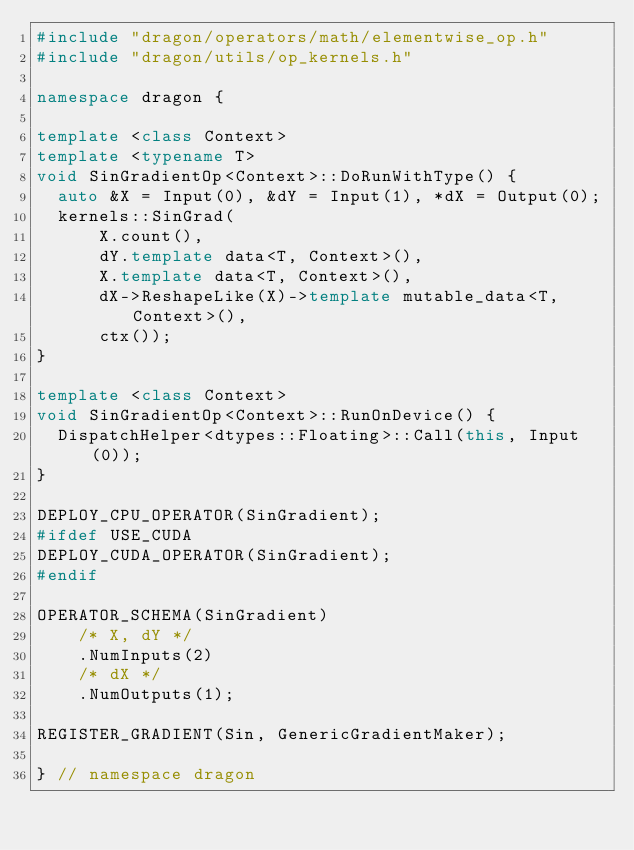<code> <loc_0><loc_0><loc_500><loc_500><_C++_>#include "dragon/operators/math/elementwise_op.h"
#include "dragon/utils/op_kernels.h"

namespace dragon {

template <class Context>
template <typename T>
void SinGradientOp<Context>::DoRunWithType() {
  auto &X = Input(0), &dY = Input(1), *dX = Output(0);
  kernels::SinGrad(
      X.count(),
      dY.template data<T, Context>(),
      X.template data<T, Context>(),
      dX->ReshapeLike(X)->template mutable_data<T, Context>(),
      ctx());
}

template <class Context>
void SinGradientOp<Context>::RunOnDevice() {
  DispatchHelper<dtypes::Floating>::Call(this, Input(0));
}

DEPLOY_CPU_OPERATOR(SinGradient);
#ifdef USE_CUDA
DEPLOY_CUDA_OPERATOR(SinGradient);
#endif

OPERATOR_SCHEMA(SinGradient)
    /* X, dY */
    .NumInputs(2)
    /* dX */
    .NumOutputs(1);

REGISTER_GRADIENT(Sin, GenericGradientMaker);

} // namespace dragon
</code> 